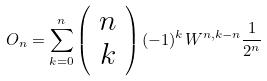<formula> <loc_0><loc_0><loc_500><loc_500>O _ { n } = \sum _ { k = 0 } ^ { n } \left ( \begin{array} { c } n \\ k \end{array} \right ) ( - 1 ) ^ { k } W ^ { n , k - n } \frac { 1 } { 2 ^ { n } }</formula> 